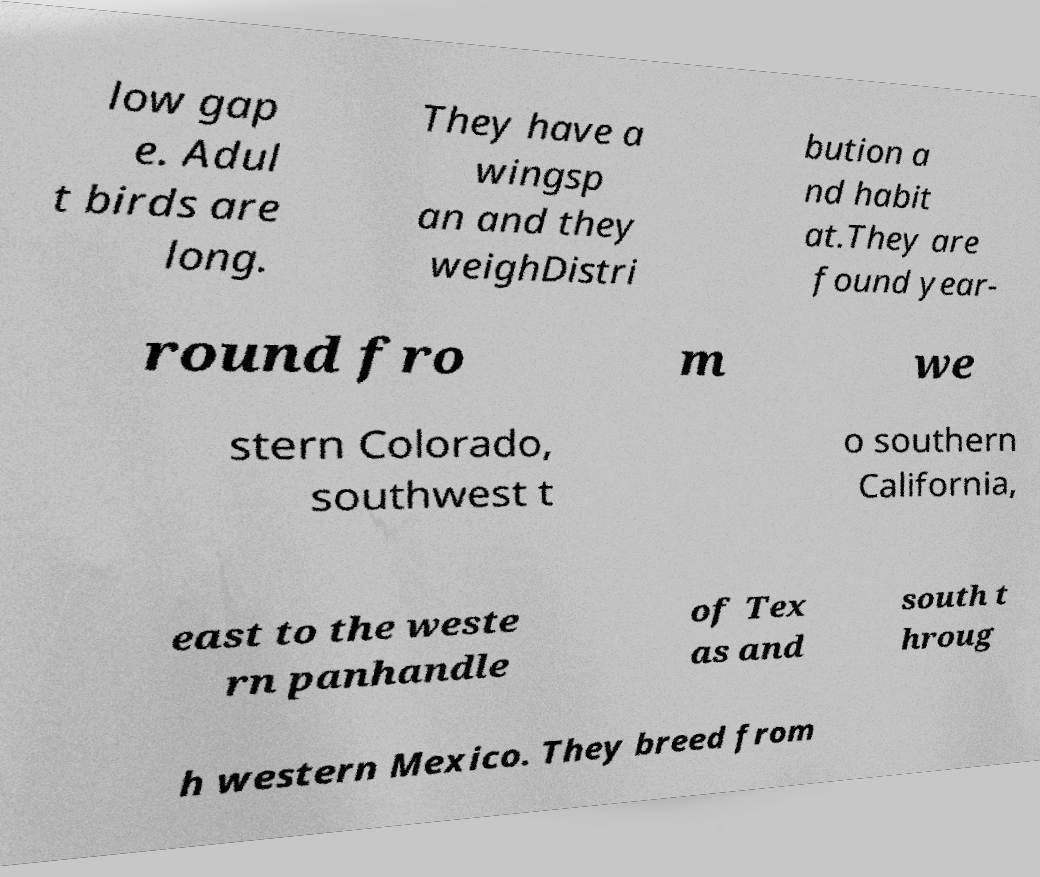For documentation purposes, I need the text within this image transcribed. Could you provide that? low gap e. Adul t birds are long. They have a wingsp an and they weighDistri bution a nd habit at.They are found year- round fro m we stern Colorado, southwest t o southern California, east to the weste rn panhandle of Tex as and south t hroug h western Mexico. They breed from 